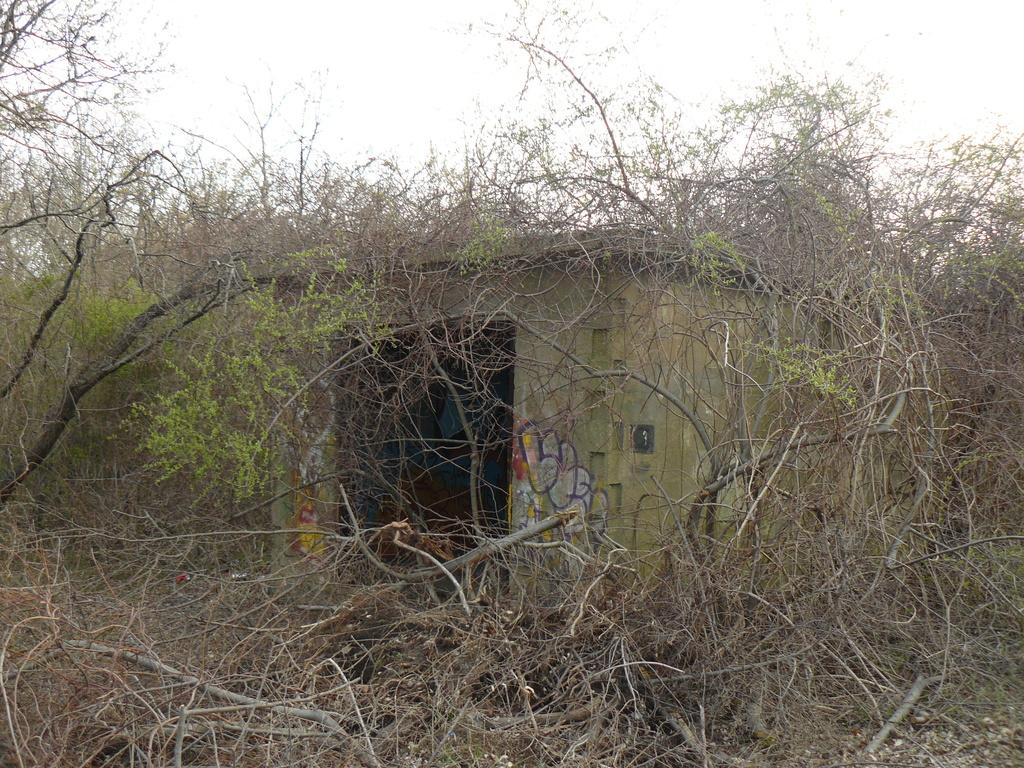What type of vegetation can be seen in the image? There are dry trees in the image. What type of structure is present in the image? There is a house in the image. What can be seen in the background of the image? The sky is visible in the background of the image. Can you see any agreements being signed in the image? There is no indication of any agreements or signings in the image. Is there a harbor visible in the image? There is no harbor present in the image; it features dry trees, a house, and the sky. Is there a girl in the image? There is no girl present in the image. 